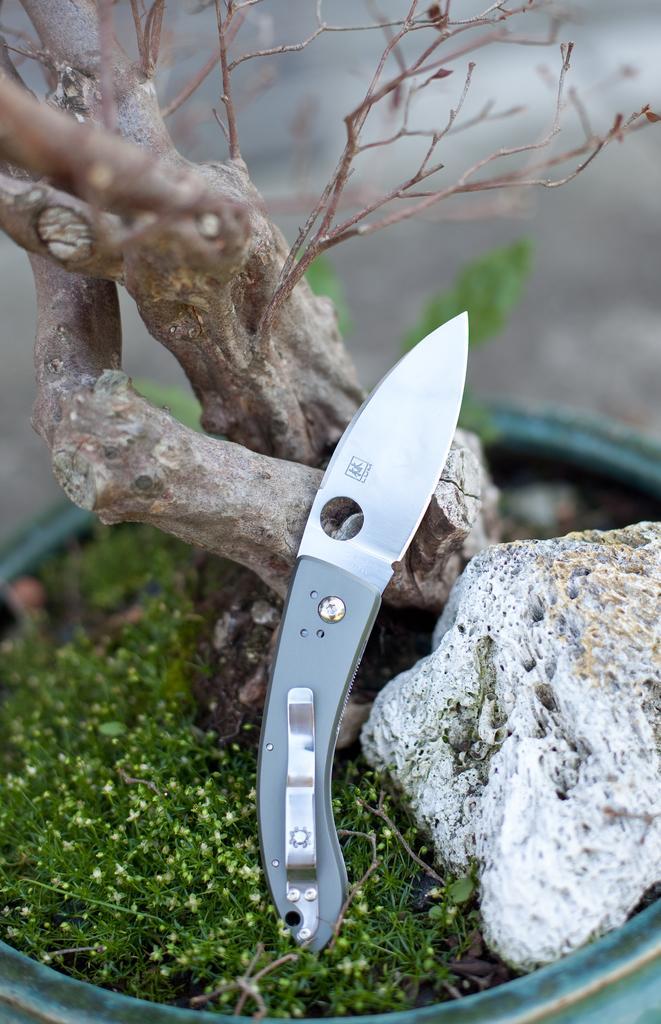In one or two sentences, can you explain what this image depicts? This is the picture of a tree, rock, knife and some plants to the side. 